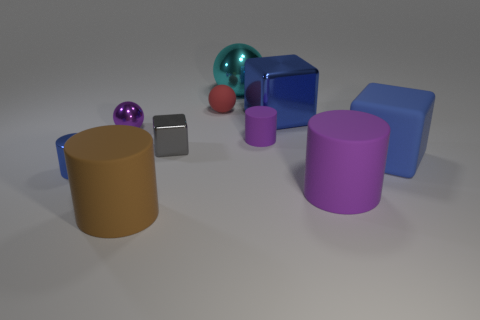Subtract all metallic balls. How many balls are left? 1 Subtract 1 blocks. How many blocks are left? 2 Subtract all brown balls. How many blue blocks are left? 2 Add 2 red matte things. How many red matte things exist? 3 Subtract all blue cylinders. How many cylinders are left? 3 Subtract 2 blue cubes. How many objects are left? 8 Subtract all cylinders. How many objects are left? 6 Subtract all green cylinders. Subtract all blue balls. How many cylinders are left? 4 Subtract all big brown matte cylinders. Subtract all large cyan shiny balls. How many objects are left? 8 Add 7 big blue objects. How many big blue objects are left? 9 